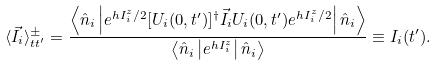Convert formula to latex. <formula><loc_0><loc_0><loc_500><loc_500>\langle \vec { I } _ { i } \rangle ^ { \pm } _ { t t ^ { \prime } } = \frac { \left \langle \hat { n } _ { i } \left | e ^ { h I _ { i } ^ { z } / 2 } [ U _ { i } ( 0 , t ^ { \prime } ) ] ^ { \dagger } \vec { I } _ { i } U _ { i } ( 0 , t ^ { \prime } ) e ^ { h I _ { i } ^ { z } / 2 } \right | \hat { n } _ { i } \right \rangle } { \left \langle \hat { n } _ { i } \left | e ^ { h I _ { i } ^ { z } } \right | \hat { n } _ { i } \right \rangle } \equiv I _ { i } ( t ^ { \prime } ) .</formula> 